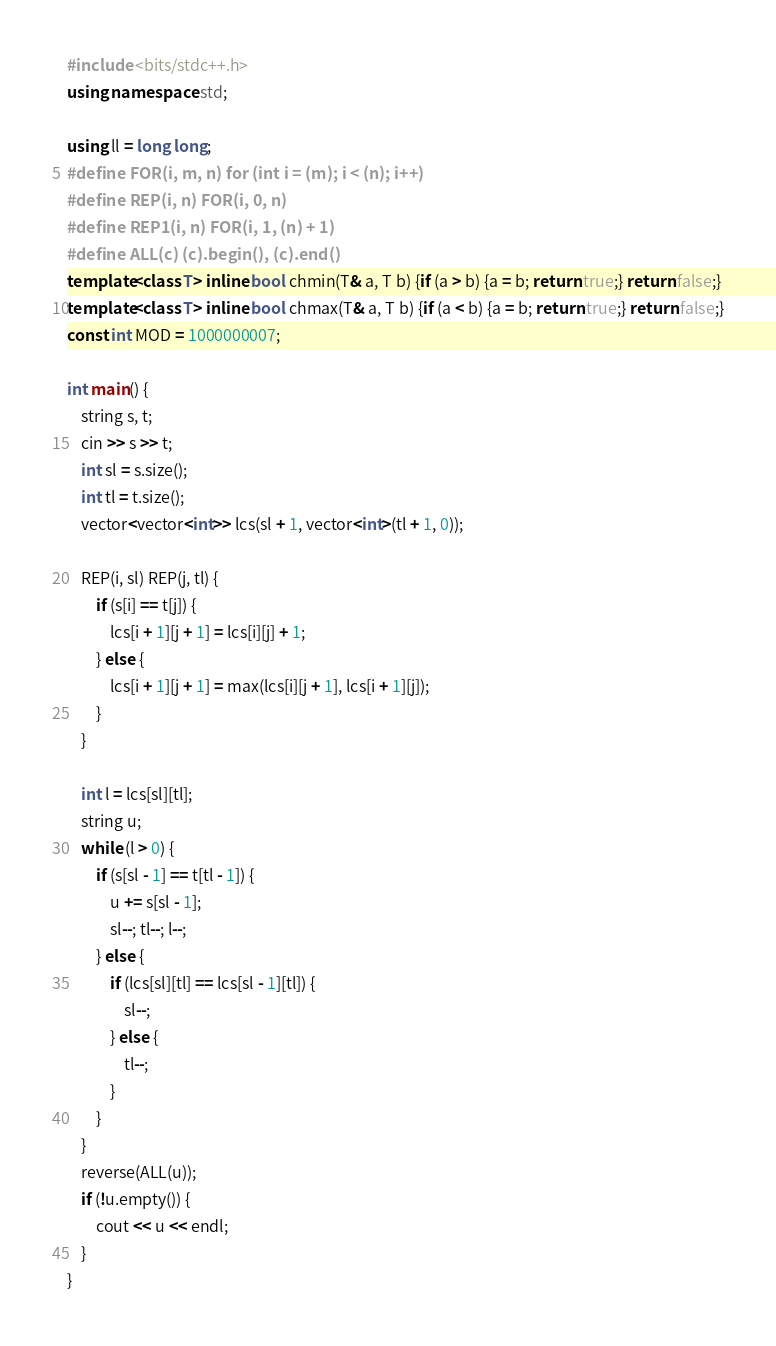Convert code to text. <code><loc_0><loc_0><loc_500><loc_500><_C++_>#include <bits/stdc++.h>
using namespace std;

using ll = long long;
#define FOR(i, m, n) for (int i = (m); i < (n); i++)
#define REP(i, n) FOR(i, 0, n)
#define REP1(i, n) FOR(i, 1, (n) + 1)
#define ALL(c) (c).begin(), (c).end()
template<class T> inline bool chmin(T& a, T b) {if (a > b) {a = b; return true;} return false;}
template<class T> inline bool chmax(T& a, T b) {if (a < b) {a = b; return true;} return false;}
const int MOD = 1000000007;

int main() {
    string s, t;
    cin >> s >> t;
    int sl = s.size();
    int tl = t.size();
    vector<vector<int>> lcs(sl + 1, vector<int>(tl + 1, 0));

    REP(i, sl) REP(j, tl) {
        if (s[i] == t[j]) {
            lcs[i + 1][j + 1] = lcs[i][j] + 1;
        } else {
            lcs[i + 1][j + 1] = max(lcs[i][j + 1], lcs[i + 1][j]);
        }
    }

    int l = lcs[sl][tl];
    string u;
    while (l > 0) {
        if (s[sl - 1] == t[tl - 1]) {
            u += s[sl - 1];
            sl--; tl--; l--;
        } else {
            if (lcs[sl][tl] == lcs[sl - 1][tl]) {
                sl--;
            } else {
                tl--;
            }
        }
    }
    reverse(ALL(u));
    if (!u.empty()) {
        cout << u << endl;
    }
}
</code> 